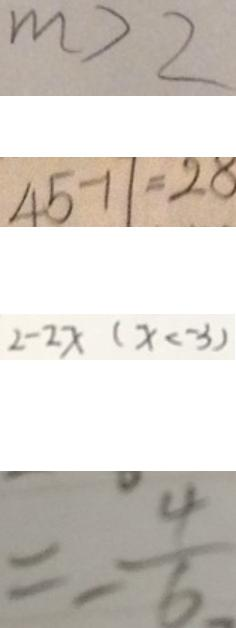<formula> <loc_0><loc_0><loc_500><loc_500>m > 2 
 4 5 - 1 1 = 2 8 
 2 - 2 x ( x < - 3 ) 
 = - \frac { 4 } { 6 }</formula> 